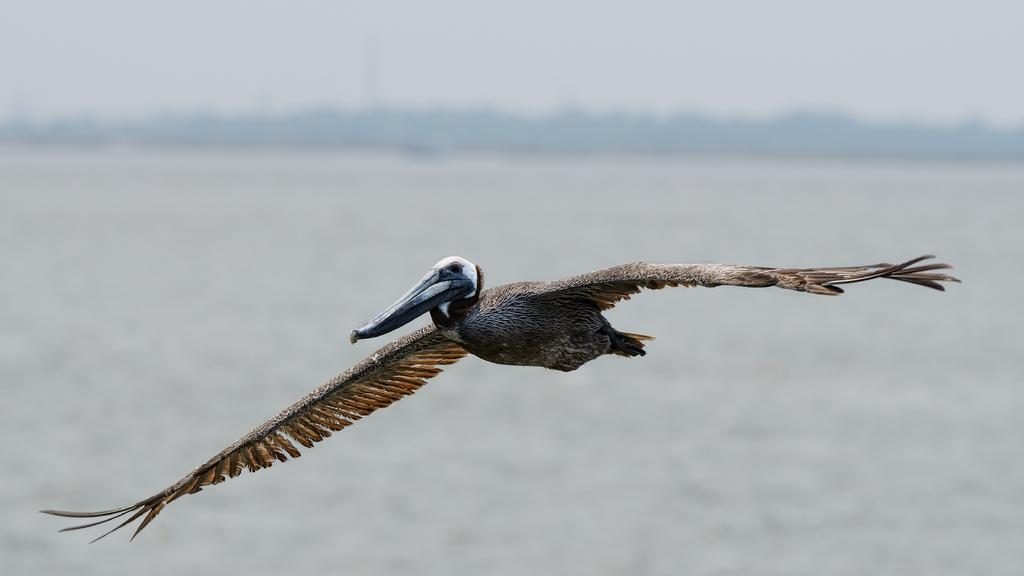What is the main subject of the image? There is a bird flying in the image. Can you describe the bird's action in the image? The bird is flying in the image. What can be inferred about the background of the image? The background of the image is not clear, so it is difficult to determine specific details about the setting. What is the topic of the discussion happening at the edge of the image? There is no discussion happening at the edge of the image, as the image only features a bird flying against an unclear background. What type of government is depicted in the image? There is no government depicted in the image, as it only features a bird flying against an unclear background. 